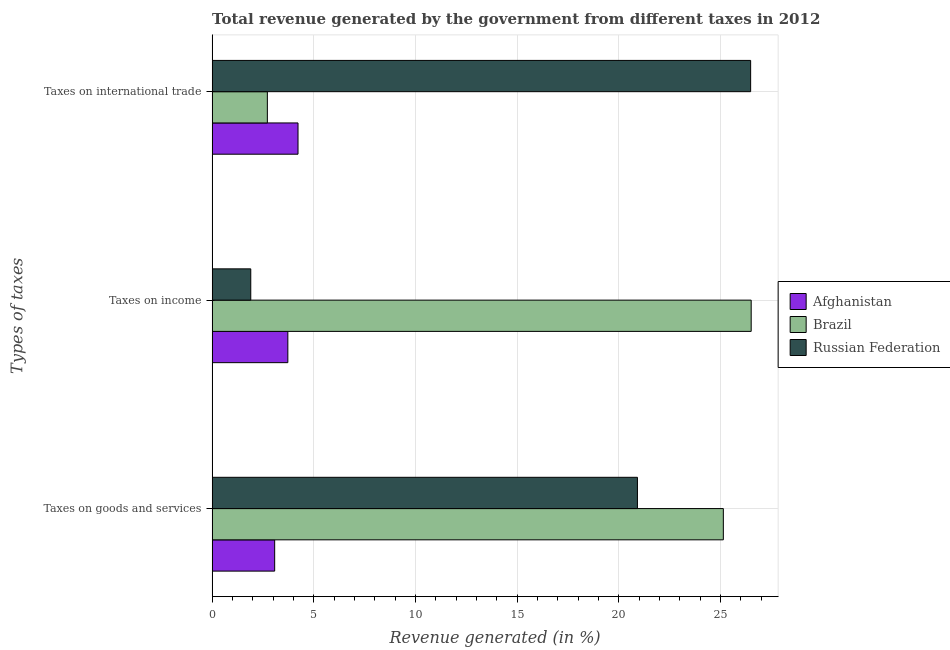How many groups of bars are there?
Your answer should be compact. 3. Are the number of bars per tick equal to the number of legend labels?
Provide a succinct answer. Yes. What is the label of the 1st group of bars from the top?
Offer a terse response. Taxes on international trade. What is the percentage of revenue generated by tax on international trade in Brazil?
Your response must be concise. 2.72. Across all countries, what is the maximum percentage of revenue generated by tax on international trade?
Your answer should be compact. 26.49. Across all countries, what is the minimum percentage of revenue generated by tax on international trade?
Make the answer very short. 2.72. In which country was the percentage of revenue generated by taxes on income minimum?
Ensure brevity in your answer.  Russian Federation. What is the total percentage of revenue generated by tax on international trade in the graph?
Provide a succinct answer. 33.43. What is the difference between the percentage of revenue generated by taxes on goods and services in Afghanistan and that in Russian Federation?
Your response must be concise. -17.84. What is the difference between the percentage of revenue generated by tax on international trade in Russian Federation and the percentage of revenue generated by taxes on goods and services in Brazil?
Your answer should be very brief. 1.34. What is the average percentage of revenue generated by taxes on income per country?
Provide a short and direct response. 10.71. What is the difference between the percentage of revenue generated by tax on international trade and percentage of revenue generated by taxes on goods and services in Russian Federation?
Provide a short and direct response. 5.57. In how many countries, is the percentage of revenue generated by taxes on goods and services greater than 19 %?
Offer a very short reply. 2. What is the ratio of the percentage of revenue generated by taxes on income in Russian Federation to that in Brazil?
Provide a short and direct response. 0.07. Is the percentage of revenue generated by taxes on goods and services in Russian Federation less than that in Afghanistan?
Provide a short and direct response. No. Is the difference between the percentage of revenue generated by taxes on goods and services in Afghanistan and Russian Federation greater than the difference between the percentage of revenue generated by tax on international trade in Afghanistan and Russian Federation?
Your answer should be compact. Yes. What is the difference between the highest and the second highest percentage of revenue generated by tax on international trade?
Give a very brief answer. 22.26. What is the difference between the highest and the lowest percentage of revenue generated by tax on international trade?
Make the answer very short. 23.77. In how many countries, is the percentage of revenue generated by taxes on goods and services greater than the average percentage of revenue generated by taxes on goods and services taken over all countries?
Ensure brevity in your answer.  2. Is the sum of the percentage of revenue generated by tax on international trade in Brazil and Russian Federation greater than the maximum percentage of revenue generated by taxes on income across all countries?
Provide a succinct answer. Yes. What does the 1st bar from the top in Taxes on income represents?
Offer a very short reply. Russian Federation. What does the 3rd bar from the bottom in Taxes on goods and services represents?
Your response must be concise. Russian Federation. Is it the case that in every country, the sum of the percentage of revenue generated by taxes on goods and services and percentage of revenue generated by taxes on income is greater than the percentage of revenue generated by tax on international trade?
Your answer should be compact. No. How many countries are there in the graph?
Give a very brief answer. 3. Are the values on the major ticks of X-axis written in scientific E-notation?
Your answer should be very brief. No. Does the graph contain any zero values?
Make the answer very short. No. Where does the legend appear in the graph?
Your answer should be compact. Center right. How many legend labels are there?
Offer a very short reply. 3. How are the legend labels stacked?
Your answer should be very brief. Vertical. What is the title of the graph?
Your answer should be very brief. Total revenue generated by the government from different taxes in 2012. Does "Haiti" appear as one of the legend labels in the graph?
Offer a terse response. No. What is the label or title of the X-axis?
Provide a short and direct response. Revenue generated (in %). What is the label or title of the Y-axis?
Offer a very short reply. Types of taxes. What is the Revenue generated (in %) in Afghanistan in Taxes on goods and services?
Keep it short and to the point. 3.08. What is the Revenue generated (in %) of Brazil in Taxes on goods and services?
Offer a very short reply. 25.14. What is the Revenue generated (in %) in Russian Federation in Taxes on goods and services?
Offer a terse response. 20.92. What is the Revenue generated (in %) in Afghanistan in Taxes on income?
Offer a terse response. 3.72. What is the Revenue generated (in %) in Brazil in Taxes on income?
Provide a short and direct response. 26.51. What is the Revenue generated (in %) of Russian Federation in Taxes on income?
Provide a succinct answer. 1.9. What is the Revenue generated (in %) in Afghanistan in Taxes on international trade?
Provide a succinct answer. 4.22. What is the Revenue generated (in %) in Brazil in Taxes on international trade?
Your answer should be very brief. 2.72. What is the Revenue generated (in %) of Russian Federation in Taxes on international trade?
Provide a short and direct response. 26.49. Across all Types of taxes, what is the maximum Revenue generated (in %) of Afghanistan?
Make the answer very short. 4.22. Across all Types of taxes, what is the maximum Revenue generated (in %) in Brazil?
Offer a very short reply. 26.51. Across all Types of taxes, what is the maximum Revenue generated (in %) in Russian Federation?
Your answer should be compact. 26.49. Across all Types of taxes, what is the minimum Revenue generated (in %) in Afghanistan?
Your answer should be compact. 3.08. Across all Types of taxes, what is the minimum Revenue generated (in %) of Brazil?
Ensure brevity in your answer.  2.72. Across all Types of taxes, what is the minimum Revenue generated (in %) of Russian Federation?
Keep it short and to the point. 1.9. What is the total Revenue generated (in %) in Afghanistan in the graph?
Offer a very short reply. 11.02. What is the total Revenue generated (in %) in Brazil in the graph?
Your answer should be compact. 54.37. What is the total Revenue generated (in %) in Russian Federation in the graph?
Ensure brevity in your answer.  49.3. What is the difference between the Revenue generated (in %) of Afghanistan in Taxes on goods and services and that in Taxes on income?
Keep it short and to the point. -0.65. What is the difference between the Revenue generated (in %) of Brazil in Taxes on goods and services and that in Taxes on income?
Make the answer very short. -1.37. What is the difference between the Revenue generated (in %) in Russian Federation in Taxes on goods and services and that in Taxes on income?
Provide a succinct answer. 19.02. What is the difference between the Revenue generated (in %) in Afghanistan in Taxes on goods and services and that in Taxes on international trade?
Keep it short and to the point. -1.15. What is the difference between the Revenue generated (in %) in Brazil in Taxes on goods and services and that in Taxes on international trade?
Make the answer very short. 22.43. What is the difference between the Revenue generated (in %) of Russian Federation in Taxes on goods and services and that in Taxes on international trade?
Offer a very short reply. -5.57. What is the difference between the Revenue generated (in %) of Afghanistan in Taxes on income and that in Taxes on international trade?
Ensure brevity in your answer.  -0.5. What is the difference between the Revenue generated (in %) of Brazil in Taxes on income and that in Taxes on international trade?
Your answer should be compact. 23.8. What is the difference between the Revenue generated (in %) in Russian Federation in Taxes on income and that in Taxes on international trade?
Ensure brevity in your answer.  -24.58. What is the difference between the Revenue generated (in %) in Afghanistan in Taxes on goods and services and the Revenue generated (in %) in Brazil in Taxes on income?
Your response must be concise. -23.44. What is the difference between the Revenue generated (in %) of Afghanistan in Taxes on goods and services and the Revenue generated (in %) of Russian Federation in Taxes on income?
Offer a very short reply. 1.18. What is the difference between the Revenue generated (in %) of Brazil in Taxes on goods and services and the Revenue generated (in %) of Russian Federation in Taxes on income?
Provide a succinct answer. 23.24. What is the difference between the Revenue generated (in %) of Afghanistan in Taxes on goods and services and the Revenue generated (in %) of Brazil in Taxes on international trade?
Give a very brief answer. 0.36. What is the difference between the Revenue generated (in %) of Afghanistan in Taxes on goods and services and the Revenue generated (in %) of Russian Federation in Taxes on international trade?
Provide a succinct answer. -23.41. What is the difference between the Revenue generated (in %) in Brazil in Taxes on goods and services and the Revenue generated (in %) in Russian Federation in Taxes on international trade?
Give a very brief answer. -1.34. What is the difference between the Revenue generated (in %) of Afghanistan in Taxes on income and the Revenue generated (in %) of Russian Federation in Taxes on international trade?
Your answer should be very brief. -22.76. What is the difference between the Revenue generated (in %) of Brazil in Taxes on income and the Revenue generated (in %) of Russian Federation in Taxes on international trade?
Keep it short and to the point. 0.03. What is the average Revenue generated (in %) in Afghanistan per Types of taxes?
Your response must be concise. 3.67. What is the average Revenue generated (in %) of Brazil per Types of taxes?
Keep it short and to the point. 18.12. What is the average Revenue generated (in %) in Russian Federation per Types of taxes?
Make the answer very short. 16.43. What is the difference between the Revenue generated (in %) in Afghanistan and Revenue generated (in %) in Brazil in Taxes on goods and services?
Your answer should be very brief. -22.07. What is the difference between the Revenue generated (in %) in Afghanistan and Revenue generated (in %) in Russian Federation in Taxes on goods and services?
Provide a succinct answer. -17.84. What is the difference between the Revenue generated (in %) of Brazil and Revenue generated (in %) of Russian Federation in Taxes on goods and services?
Ensure brevity in your answer.  4.22. What is the difference between the Revenue generated (in %) in Afghanistan and Revenue generated (in %) in Brazil in Taxes on income?
Offer a very short reply. -22.79. What is the difference between the Revenue generated (in %) of Afghanistan and Revenue generated (in %) of Russian Federation in Taxes on income?
Offer a very short reply. 1.82. What is the difference between the Revenue generated (in %) of Brazil and Revenue generated (in %) of Russian Federation in Taxes on income?
Provide a succinct answer. 24.61. What is the difference between the Revenue generated (in %) in Afghanistan and Revenue generated (in %) in Brazil in Taxes on international trade?
Offer a terse response. 1.51. What is the difference between the Revenue generated (in %) of Afghanistan and Revenue generated (in %) of Russian Federation in Taxes on international trade?
Ensure brevity in your answer.  -22.26. What is the difference between the Revenue generated (in %) in Brazil and Revenue generated (in %) in Russian Federation in Taxes on international trade?
Make the answer very short. -23.77. What is the ratio of the Revenue generated (in %) of Afghanistan in Taxes on goods and services to that in Taxes on income?
Your response must be concise. 0.83. What is the ratio of the Revenue generated (in %) in Brazil in Taxes on goods and services to that in Taxes on income?
Keep it short and to the point. 0.95. What is the ratio of the Revenue generated (in %) of Russian Federation in Taxes on goods and services to that in Taxes on income?
Offer a very short reply. 11.01. What is the ratio of the Revenue generated (in %) in Afghanistan in Taxes on goods and services to that in Taxes on international trade?
Give a very brief answer. 0.73. What is the ratio of the Revenue generated (in %) in Brazil in Taxes on goods and services to that in Taxes on international trade?
Make the answer very short. 9.26. What is the ratio of the Revenue generated (in %) of Russian Federation in Taxes on goods and services to that in Taxes on international trade?
Provide a succinct answer. 0.79. What is the ratio of the Revenue generated (in %) of Afghanistan in Taxes on income to that in Taxes on international trade?
Make the answer very short. 0.88. What is the ratio of the Revenue generated (in %) in Brazil in Taxes on income to that in Taxes on international trade?
Provide a succinct answer. 9.76. What is the ratio of the Revenue generated (in %) in Russian Federation in Taxes on income to that in Taxes on international trade?
Provide a succinct answer. 0.07. What is the difference between the highest and the second highest Revenue generated (in %) in Afghanistan?
Your answer should be very brief. 0.5. What is the difference between the highest and the second highest Revenue generated (in %) in Brazil?
Your response must be concise. 1.37. What is the difference between the highest and the second highest Revenue generated (in %) of Russian Federation?
Your answer should be very brief. 5.57. What is the difference between the highest and the lowest Revenue generated (in %) of Afghanistan?
Give a very brief answer. 1.15. What is the difference between the highest and the lowest Revenue generated (in %) of Brazil?
Your answer should be compact. 23.8. What is the difference between the highest and the lowest Revenue generated (in %) of Russian Federation?
Provide a short and direct response. 24.58. 